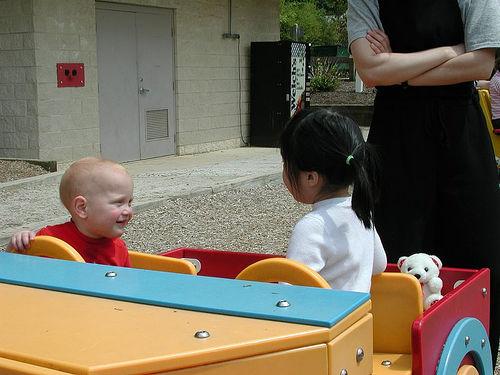Are the kids having a good time?
Be succinct. Yes. Which child is youngest?
Give a very brief answer. Boy. What is located on the right door, lower part?
Quick response, please. Vent. 